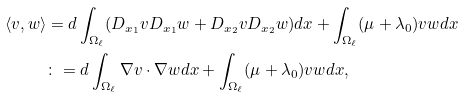Convert formula to latex. <formula><loc_0><loc_0><loc_500><loc_500>\langle v , w \rangle & = d \int _ { \Omega _ { \ell } } ( D _ { x _ { 1 } } v D _ { x _ { 1 } } w + D _ { x _ { 2 } } v D _ { x _ { 2 } } w ) d x + \int _ { \Omega _ { \ell } } ( \mu + \lambda _ { 0 } ) v w d x \\ & \colon = d \int _ { \Omega _ { \ell } } \nabla v \cdot \nabla w d x + \int _ { \Omega _ { \ell } } ( \mu + \lambda _ { 0 } ) v w d x ,</formula> 